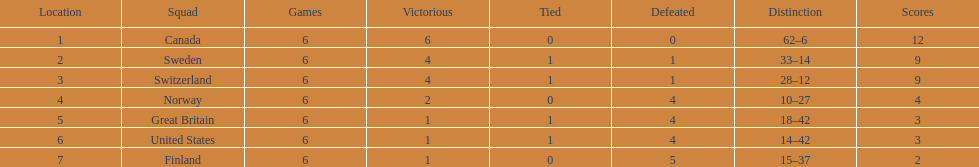Which country performed better during the 1951 world ice hockey championships, switzerland or great britain? Switzerland. 